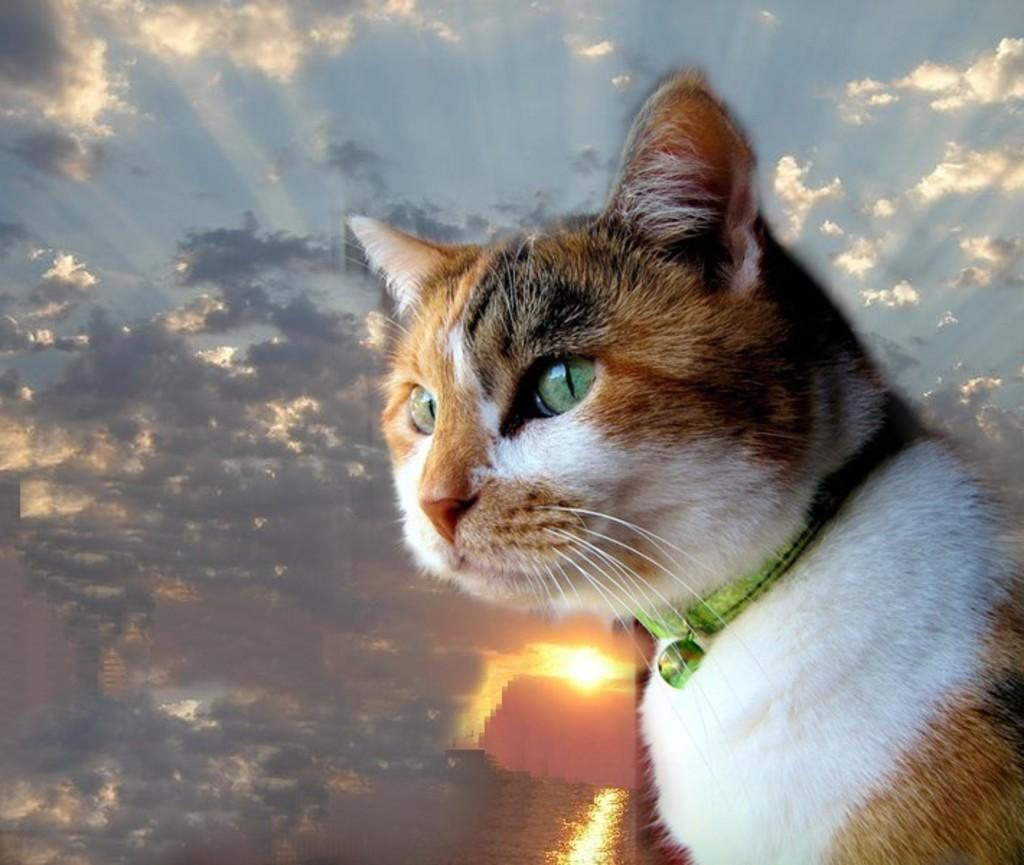What animal is located on the right side of the image? There is a cat on the right side of the image. What can be seen in the background of the image? The sky is visible in the background of the image. What type of weather can be inferred from the background? The presence of clouds in the background suggests that it might be a partly cloudy day. Can the sun be seen in the image? Yes, the sun is observable in the sky. What type of net is being used to catch the cat's face in the image? There is no net present in the image, and the cat's face is not being caught by any object. 